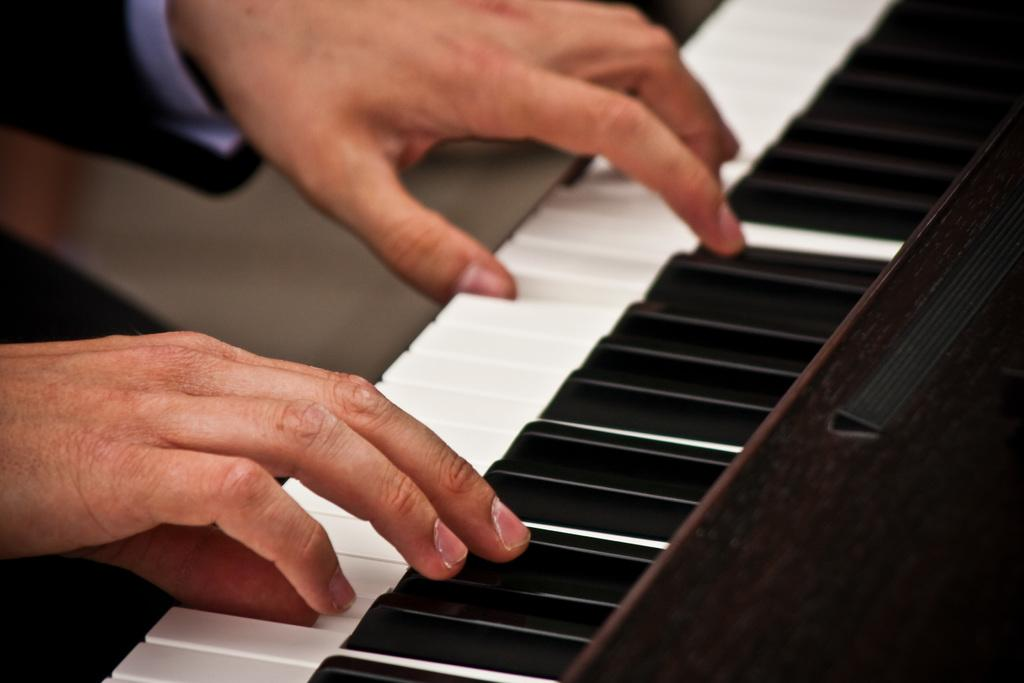What body parts are visible in the image? There are human hands in the image. What are the hands doing in the image? The hands are on piano keys. What type of hat is the leaf wearing in the image? There is no hat or leaf present in the image; it features human hands on piano keys. 